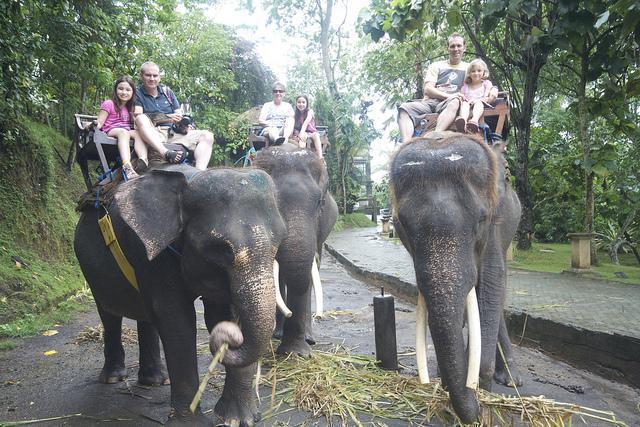What is hoisted atop the elephants to help the people ride them?
Indicate the correct response by choosing from the four available options to answer the question.
Options: Saddles, benches, harnesses, blankets. Benches. How many elephants are standing in the road with people on their backs?
Indicate the correct response by choosing from the four available options to answer the question.
Options: Four, three, five, six. Three. 